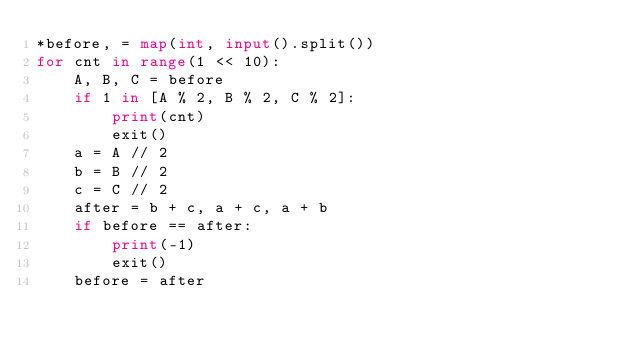<code> <loc_0><loc_0><loc_500><loc_500><_Python_>*before, = map(int, input().split())
for cnt in range(1 << 10):
    A, B, C = before
    if 1 in [A % 2, B % 2, C % 2]:
        print(cnt)
        exit()
    a = A // 2
    b = B // 2
    c = C // 2
    after = b + c, a + c, a + b
    if before == after:
        print(-1)
        exit()
    before = after</code> 